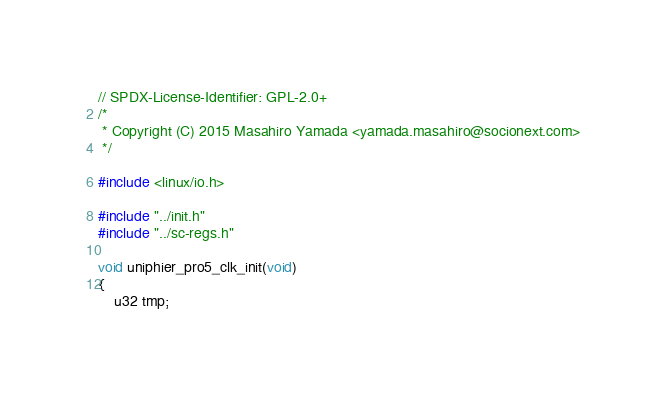<code> <loc_0><loc_0><loc_500><loc_500><_C_>// SPDX-License-Identifier: GPL-2.0+
/*
 * Copyright (C) 2015 Masahiro Yamada <yamada.masahiro@socionext.com>
 */

#include <linux/io.h>

#include "../init.h"
#include "../sc-regs.h"

void uniphier_pro5_clk_init(void)
{
	u32 tmp;
</code> 